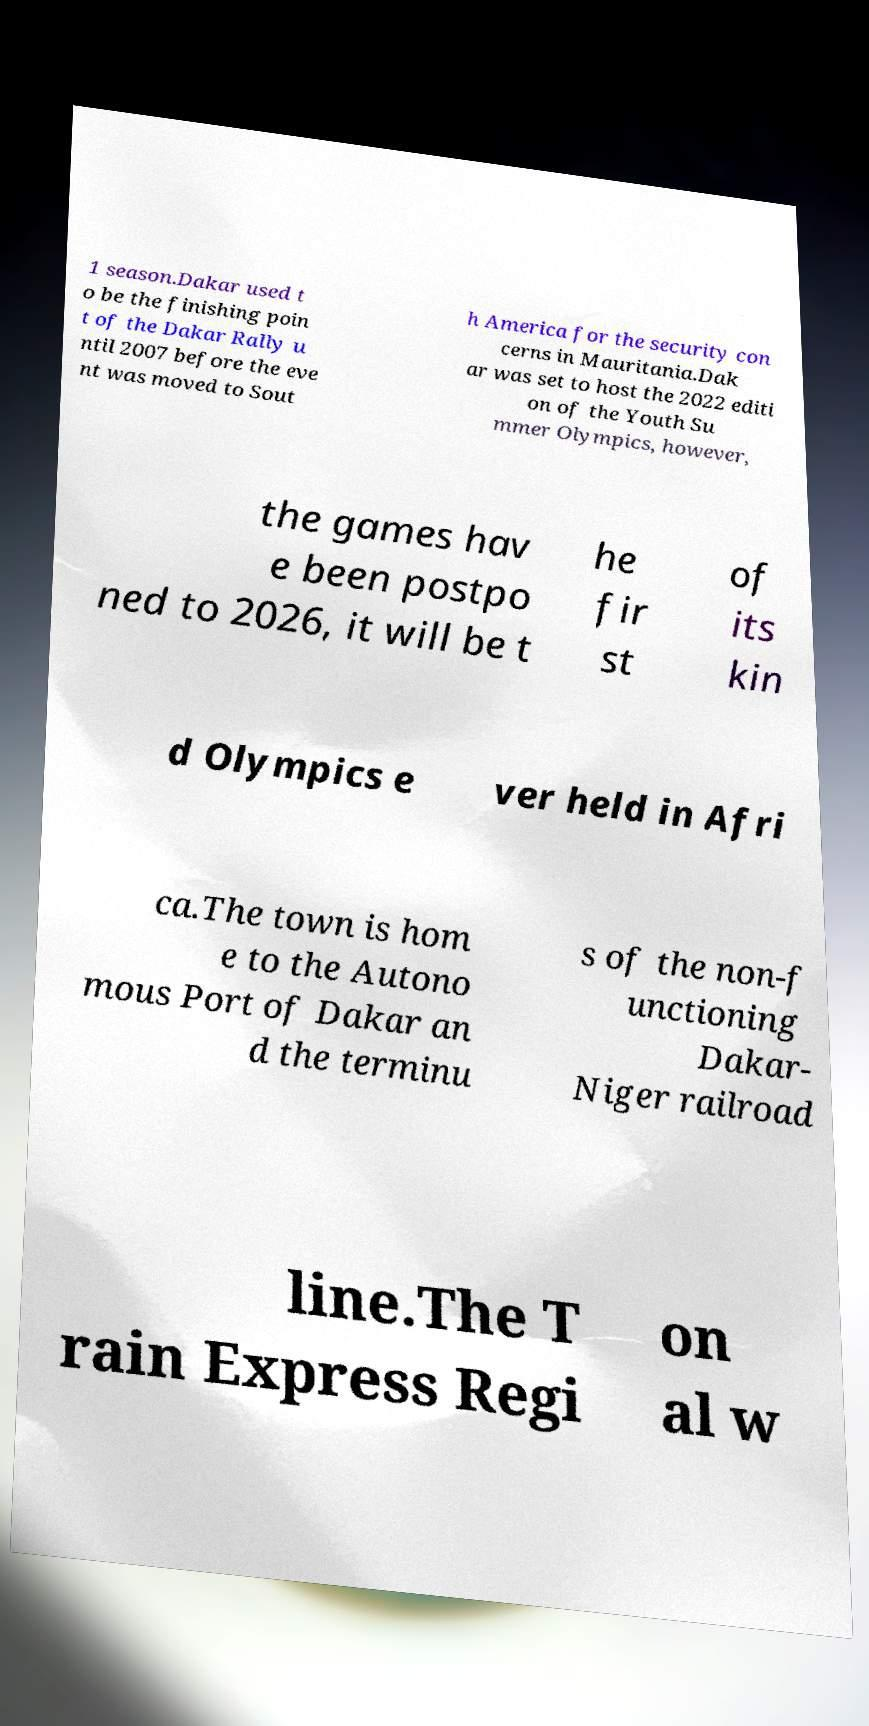There's text embedded in this image that I need extracted. Can you transcribe it verbatim? 1 season.Dakar used t o be the finishing poin t of the Dakar Rally u ntil 2007 before the eve nt was moved to Sout h America for the security con cerns in Mauritania.Dak ar was set to host the 2022 editi on of the Youth Su mmer Olympics, however, the games hav e been postpo ned to 2026, it will be t he fir st of its kin d Olympics e ver held in Afri ca.The town is hom e to the Autono mous Port of Dakar an d the terminu s of the non-f unctioning Dakar- Niger railroad line.The T rain Express Regi on al w 